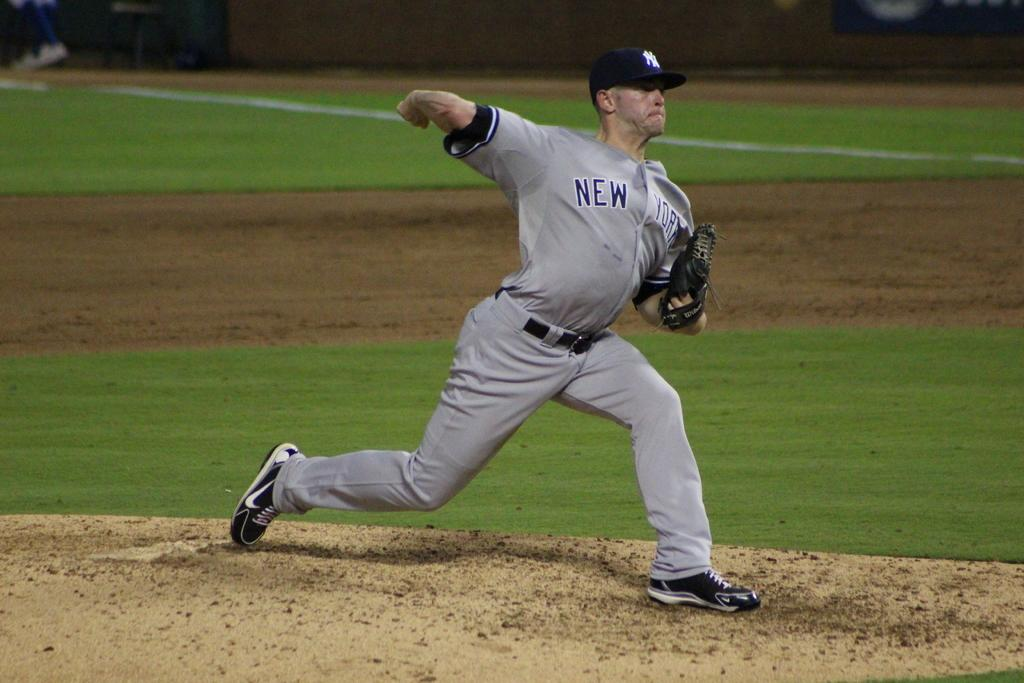<image>
Give a short and clear explanation of the subsequent image. Man playing for the New York baseball team about to pitch a ball. 